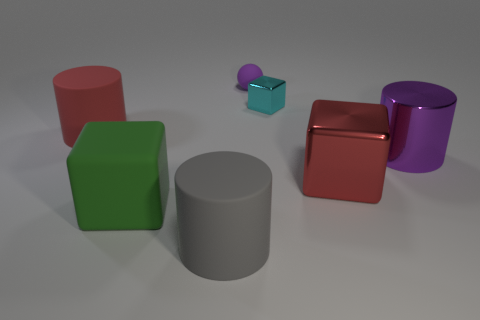What number of big objects are both to the right of the large green object and on the left side of the tiny cyan shiny cube?
Give a very brief answer. 1. What material is the green object?
Your answer should be compact. Rubber. The red metal object that is the same size as the metal cylinder is what shape?
Offer a very short reply. Cube. Does the red object right of the small purple rubber thing have the same material as the tiny thing that is in front of the small rubber ball?
Your answer should be compact. Yes. What number of purple metal objects are there?
Offer a terse response. 1. What number of big green things are the same shape as the tiny cyan object?
Offer a very short reply. 1. Does the big purple shiny object have the same shape as the cyan metal object?
Ensure brevity in your answer.  No. The purple metallic cylinder is what size?
Provide a succinct answer. Large. How many rubber objects are the same size as the red matte cylinder?
Provide a succinct answer. 2. There is a rubber cylinder that is behind the red shiny object; is it the same size as the block on the left side of the tiny cyan metal cube?
Offer a terse response. Yes. 